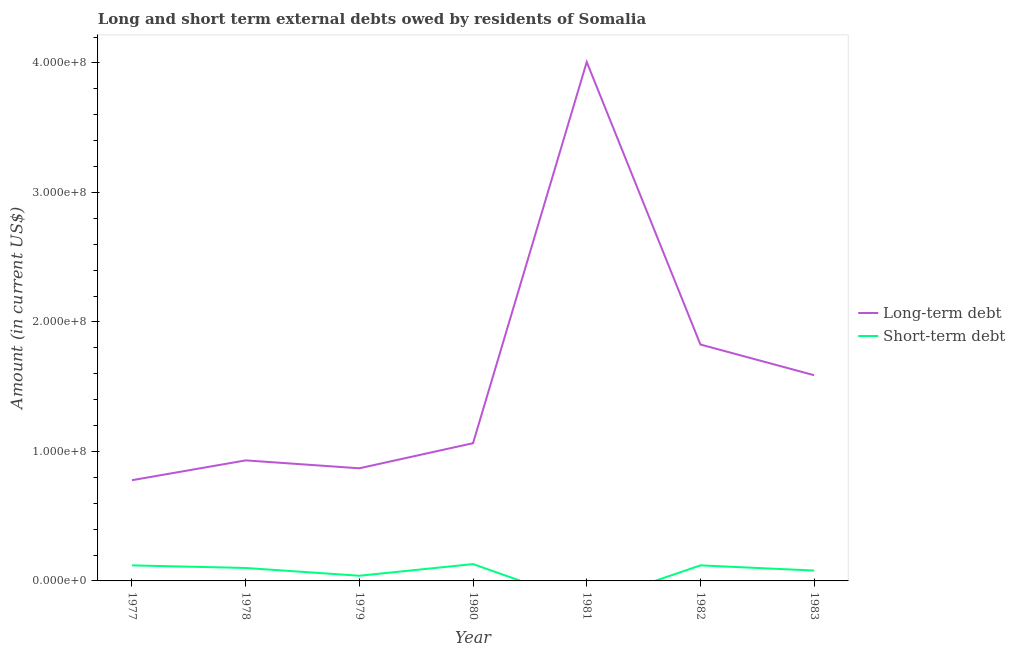What is the short-term debts owed by residents in 1982?
Your answer should be very brief. 1.20e+07. Across all years, what is the maximum long-term debts owed by residents?
Ensure brevity in your answer.  4.01e+08. Across all years, what is the minimum long-term debts owed by residents?
Offer a terse response. 7.78e+07. What is the total short-term debts owed by residents in the graph?
Provide a short and direct response. 5.90e+07. What is the difference between the short-term debts owed by residents in 1978 and that in 1980?
Your answer should be compact. -3.00e+06. What is the difference between the long-term debts owed by residents in 1979 and the short-term debts owed by residents in 1982?
Provide a succinct answer. 7.50e+07. What is the average short-term debts owed by residents per year?
Provide a succinct answer. 8.43e+06. In the year 1982, what is the difference between the short-term debts owed by residents and long-term debts owed by residents?
Make the answer very short. -1.71e+08. What is the ratio of the long-term debts owed by residents in 1977 to that in 1981?
Give a very brief answer. 0.19. Is the difference between the long-term debts owed by residents in 1977 and 1978 greater than the difference between the short-term debts owed by residents in 1977 and 1978?
Your answer should be compact. No. What is the difference between the highest and the second highest long-term debts owed by residents?
Your response must be concise. 2.18e+08. What is the difference between the highest and the lowest short-term debts owed by residents?
Ensure brevity in your answer.  1.30e+07. Does the short-term debts owed by residents monotonically increase over the years?
Give a very brief answer. No. Is the long-term debts owed by residents strictly greater than the short-term debts owed by residents over the years?
Provide a short and direct response. Yes. How many lines are there?
Offer a terse response. 2. What is the difference between two consecutive major ticks on the Y-axis?
Offer a very short reply. 1.00e+08. Are the values on the major ticks of Y-axis written in scientific E-notation?
Your answer should be compact. Yes. Does the graph contain any zero values?
Make the answer very short. Yes. How many legend labels are there?
Provide a short and direct response. 2. What is the title of the graph?
Provide a succinct answer. Long and short term external debts owed by residents of Somalia. Does "Savings" appear as one of the legend labels in the graph?
Ensure brevity in your answer.  No. What is the label or title of the Y-axis?
Provide a short and direct response. Amount (in current US$). What is the Amount (in current US$) of Long-term debt in 1977?
Keep it short and to the point. 7.78e+07. What is the Amount (in current US$) of Long-term debt in 1978?
Give a very brief answer. 9.31e+07. What is the Amount (in current US$) in Short-term debt in 1978?
Your answer should be very brief. 1.00e+07. What is the Amount (in current US$) in Long-term debt in 1979?
Make the answer very short. 8.70e+07. What is the Amount (in current US$) in Short-term debt in 1979?
Your answer should be compact. 4.00e+06. What is the Amount (in current US$) of Long-term debt in 1980?
Make the answer very short. 1.06e+08. What is the Amount (in current US$) of Short-term debt in 1980?
Offer a terse response. 1.30e+07. What is the Amount (in current US$) in Long-term debt in 1981?
Offer a terse response. 4.01e+08. What is the Amount (in current US$) of Long-term debt in 1982?
Offer a terse response. 1.83e+08. What is the Amount (in current US$) in Short-term debt in 1982?
Keep it short and to the point. 1.20e+07. What is the Amount (in current US$) of Long-term debt in 1983?
Provide a succinct answer. 1.59e+08. Across all years, what is the maximum Amount (in current US$) in Long-term debt?
Your answer should be very brief. 4.01e+08. Across all years, what is the maximum Amount (in current US$) of Short-term debt?
Give a very brief answer. 1.30e+07. Across all years, what is the minimum Amount (in current US$) in Long-term debt?
Ensure brevity in your answer.  7.78e+07. Across all years, what is the minimum Amount (in current US$) in Short-term debt?
Your response must be concise. 0. What is the total Amount (in current US$) of Long-term debt in the graph?
Offer a very short reply. 1.11e+09. What is the total Amount (in current US$) of Short-term debt in the graph?
Provide a short and direct response. 5.90e+07. What is the difference between the Amount (in current US$) of Long-term debt in 1977 and that in 1978?
Keep it short and to the point. -1.53e+07. What is the difference between the Amount (in current US$) in Short-term debt in 1977 and that in 1978?
Your answer should be compact. 2.00e+06. What is the difference between the Amount (in current US$) of Long-term debt in 1977 and that in 1979?
Keep it short and to the point. -9.20e+06. What is the difference between the Amount (in current US$) of Long-term debt in 1977 and that in 1980?
Provide a succinct answer. -2.86e+07. What is the difference between the Amount (in current US$) of Long-term debt in 1977 and that in 1981?
Ensure brevity in your answer.  -3.23e+08. What is the difference between the Amount (in current US$) in Long-term debt in 1977 and that in 1982?
Keep it short and to the point. -1.05e+08. What is the difference between the Amount (in current US$) of Short-term debt in 1977 and that in 1982?
Provide a succinct answer. 0. What is the difference between the Amount (in current US$) of Long-term debt in 1977 and that in 1983?
Give a very brief answer. -8.11e+07. What is the difference between the Amount (in current US$) in Long-term debt in 1978 and that in 1979?
Your answer should be very brief. 6.11e+06. What is the difference between the Amount (in current US$) of Long-term debt in 1978 and that in 1980?
Your answer should be compact. -1.33e+07. What is the difference between the Amount (in current US$) of Long-term debt in 1978 and that in 1981?
Ensure brevity in your answer.  -3.08e+08. What is the difference between the Amount (in current US$) of Long-term debt in 1978 and that in 1982?
Provide a succinct answer. -8.95e+07. What is the difference between the Amount (in current US$) of Short-term debt in 1978 and that in 1982?
Ensure brevity in your answer.  -2.00e+06. What is the difference between the Amount (in current US$) in Long-term debt in 1978 and that in 1983?
Ensure brevity in your answer.  -6.58e+07. What is the difference between the Amount (in current US$) in Short-term debt in 1978 and that in 1983?
Keep it short and to the point. 2.00e+06. What is the difference between the Amount (in current US$) in Long-term debt in 1979 and that in 1980?
Your response must be concise. -1.94e+07. What is the difference between the Amount (in current US$) in Short-term debt in 1979 and that in 1980?
Give a very brief answer. -9.00e+06. What is the difference between the Amount (in current US$) of Long-term debt in 1979 and that in 1981?
Ensure brevity in your answer.  -3.14e+08. What is the difference between the Amount (in current US$) of Long-term debt in 1979 and that in 1982?
Your response must be concise. -9.56e+07. What is the difference between the Amount (in current US$) in Short-term debt in 1979 and that in 1982?
Give a very brief answer. -8.00e+06. What is the difference between the Amount (in current US$) of Long-term debt in 1979 and that in 1983?
Ensure brevity in your answer.  -7.19e+07. What is the difference between the Amount (in current US$) in Short-term debt in 1979 and that in 1983?
Provide a short and direct response. -4.00e+06. What is the difference between the Amount (in current US$) in Long-term debt in 1980 and that in 1981?
Provide a succinct answer. -2.94e+08. What is the difference between the Amount (in current US$) in Long-term debt in 1980 and that in 1982?
Keep it short and to the point. -7.62e+07. What is the difference between the Amount (in current US$) in Short-term debt in 1980 and that in 1982?
Provide a short and direct response. 1.00e+06. What is the difference between the Amount (in current US$) of Long-term debt in 1980 and that in 1983?
Your response must be concise. -5.25e+07. What is the difference between the Amount (in current US$) in Long-term debt in 1981 and that in 1982?
Give a very brief answer. 2.18e+08. What is the difference between the Amount (in current US$) of Long-term debt in 1981 and that in 1983?
Provide a succinct answer. 2.42e+08. What is the difference between the Amount (in current US$) of Long-term debt in 1982 and that in 1983?
Provide a succinct answer. 2.37e+07. What is the difference between the Amount (in current US$) in Long-term debt in 1977 and the Amount (in current US$) in Short-term debt in 1978?
Provide a succinct answer. 6.78e+07. What is the difference between the Amount (in current US$) of Long-term debt in 1977 and the Amount (in current US$) of Short-term debt in 1979?
Make the answer very short. 7.38e+07. What is the difference between the Amount (in current US$) in Long-term debt in 1977 and the Amount (in current US$) in Short-term debt in 1980?
Provide a short and direct response. 6.48e+07. What is the difference between the Amount (in current US$) of Long-term debt in 1977 and the Amount (in current US$) of Short-term debt in 1982?
Give a very brief answer. 6.58e+07. What is the difference between the Amount (in current US$) in Long-term debt in 1977 and the Amount (in current US$) in Short-term debt in 1983?
Make the answer very short. 6.98e+07. What is the difference between the Amount (in current US$) of Long-term debt in 1978 and the Amount (in current US$) of Short-term debt in 1979?
Give a very brief answer. 8.91e+07. What is the difference between the Amount (in current US$) of Long-term debt in 1978 and the Amount (in current US$) of Short-term debt in 1980?
Your answer should be very brief. 8.01e+07. What is the difference between the Amount (in current US$) of Long-term debt in 1978 and the Amount (in current US$) of Short-term debt in 1982?
Your answer should be compact. 8.11e+07. What is the difference between the Amount (in current US$) in Long-term debt in 1978 and the Amount (in current US$) in Short-term debt in 1983?
Keep it short and to the point. 8.51e+07. What is the difference between the Amount (in current US$) of Long-term debt in 1979 and the Amount (in current US$) of Short-term debt in 1980?
Make the answer very short. 7.40e+07. What is the difference between the Amount (in current US$) in Long-term debt in 1979 and the Amount (in current US$) in Short-term debt in 1982?
Your answer should be very brief. 7.50e+07. What is the difference between the Amount (in current US$) in Long-term debt in 1979 and the Amount (in current US$) in Short-term debt in 1983?
Make the answer very short. 7.90e+07. What is the difference between the Amount (in current US$) in Long-term debt in 1980 and the Amount (in current US$) in Short-term debt in 1982?
Ensure brevity in your answer.  9.44e+07. What is the difference between the Amount (in current US$) in Long-term debt in 1980 and the Amount (in current US$) in Short-term debt in 1983?
Offer a very short reply. 9.84e+07. What is the difference between the Amount (in current US$) in Long-term debt in 1981 and the Amount (in current US$) in Short-term debt in 1982?
Provide a succinct answer. 3.89e+08. What is the difference between the Amount (in current US$) in Long-term debt in 1981 and the Amount (in current US$) in Short-term debt in 1983?
Keep it short and to the point. 3.93e+08. What is the difference between the Amount (in current US$) of Long-term debt in 1982 and the Amount (in current US$) of Short-term debt in 1983?
Offer a terse response. 1.75e+08. What is the average Amount (in current US$) of Long-term debt per year?
Offer a terse response. 1.58e+08. What is the average Amount (in current US$) in Short-term debt per year?
Your response must be concise. 8.43e+06. In the year 1977, what is the difference between the Amount (in current US$) of Long-term debt and Amount (in current US$) of Short-term debt?
Your answer should be very brief. 6.58e+07. In the year 1978, what is the difference between the Amount (in current US$) of Long-term debt and Amount (in current US$) of Short-term debt?
Your answer should be compact. 8.31e+07. In the year 1979, what is the difference between the Amount (in current US$) of Long-term debt and Amount (in current US$) of Short-term debt?
Provide a short and direct response. 8.30e+07. In the year 1980, what is the difference between the Amount (in current US$) in Long-term debt and Amount (in current US$) in Short-term debt?
Provide a succinct answer. 9.34e+07. In the year 1982, what is the difference between the Amount (in current US$) in Long-term debt and Amount (in current US$) in Short-term debt?
Ensure brevity in your answer.  1.71e+08. In the year 1983, what is the difference between the Amount (in current US$) of Long-term debt and Amount (in current US$) of Short-term debt?
Keep it short and to the point. 1.51e+08. What is the ratio of the Amount (in current US$) of Long-term debt in 1977 to that in 1978?
Ensure brevity in your answer.  0.84. What is the ratio of the Amount (in current US$) in Long-term debt in 1977 to that in 1979?
Provide a succinct answer. 0.89. What is the ratio of the Amount (in current US$) of Long-term debt in 1977 to that in 1980?
Your answer should be very brief. 0.73. What is the ratio of the Amount (in current US$) of Short-term debt in 1977 to that in 1980?
Ensure brevity in your answer.  0.92. What is the ratio of the Amount (in current US$) of Long-term debt in 1977 to that in 1981?
Provide a succinct answer. 0.19. What is the ratio of the Amount (in current US$) of Long-term debt in 1977 to that in 1982?
Offer a terse response. 0.43. What is the ratio of the Amount (in current US$) in Short-term debt in 1977 to that in 1982?
Keep it short and to the point. 1. What is the ratio of the Amount (in current US$) of Long-term debt in 1977 to that in 1983?
Your response must be concise. 0.49. What is the ratio of the Amount (in current US$) in Long-term debt in 1978 to that in 1979?
Ensure brevity in your answer.  1.07. What is the ratio of the Amount (in current US$) in Long-term debt in 1978 to that in 1980?
Make the answer very short. 0.88. What is the ratio of the Amount (in current US$) of Short-term debt in 1978 to that in 1980?
Ensure brevity in your answer.  0.77. What is the ratio of the Amount (in current US$) in Long-term debt in 1978 to that in 1981?
Your answer should be very brief. 0.23. What is the ratio of the Amount (in current US$) in Long-term debt in 1978 to that in 1982?
Your answer should be compact. 0.51. What is the ratio of the Amount (in current US$) in Short-term debt in 1978 to that in 1982?
Offer a terse response. 0.83. What is the ratio of the Amount (in current US$) of Long-term debt in 1978 to that in 1983?
Provide a succinct answer. 0.59. What is the ratio of the Amount (in current US$) in Short-term debt in 1978 to that in 1983?
Your response must be concise. 1.25. What is the ratio of the Amount (in current US$) of Long-term debt in 1979 to that in 1980?
Keep it short and to the point. 0.82. What is the ratio of the Amount (in current US$) of Short-term debt in 1979 to that in 1980?
Your answer should be compact. 0.31. What is the ratio of the Amount (in current US$) in Long-term debt in 1979 to that in 1981?
Provide a short and direct response. 0.22. What is the ratio of the Amount (in current US$) of Long-term debt in 1979 to that in 1982?
Keep it short and to the point. 0.48. What is the ratio of the Amount (in current US$) in Short-term debt in 1979 to that in 1982?
Your response must be concise. 0.33. What is the ratio of the Amount (in current US$) of Long-term debt in 1979 to that in 1983?
Ensure brevity in your answer.  0.55. What is the ratio of the Amount (in current US$) in Long-term debt in 1980 to that in 1981?
Ensure brevity in your answer.  0.27. What is the ratio of the Amount (in current US$) in Long-term debt in 1980 to that in 1982?
Provide a succinct answer. 0.58. What is the ratio of the Amount (in current US$) of Short-term debt in 1980 to that in 1982?
Offer a very short reply. 1.08. What is the ratio of the Amount (in current US$) of Long-term debt in 1980 to that in 1983?
Your answer should be compact. 0.67. What is the ratio of the Amount (in current US$) in Short-term debt in 1980 to that in 1983?
Offer a terse response. 1.62. What is the ratio of the Amount (in current US$) in Long-term debt in 1981 to that in 1982?
Ensure brevity in your answer.  2.2. What is the ratio of the Amount (in current US$) in Long-term debt in 1981 to that in 1983?
Your answer should be compact. 2.52. What is the ratio of the Amount (in current US$) of Long-term debt in 1982 to that in 1983?
Your answer should be compact. 1.15. What is the ratio of the Amount (in current US$) in Short-term debt in 1982 to that in 1983?
Give a very brief answer. 1.5. What is the difference between the highest and the second highest Amount (in current US$) of Long-term debt?
Your answer should be very brief. 2.18e+08. What is the difference between the highest and the lowest Amount (in current US$) in Long-term debt?
Make the answer very short. 3.23e+08. What is the difference between the highest and the lowest Amount (in current US$) in Short-term debt?
Your answer should be very brief. 1.30e+07. 